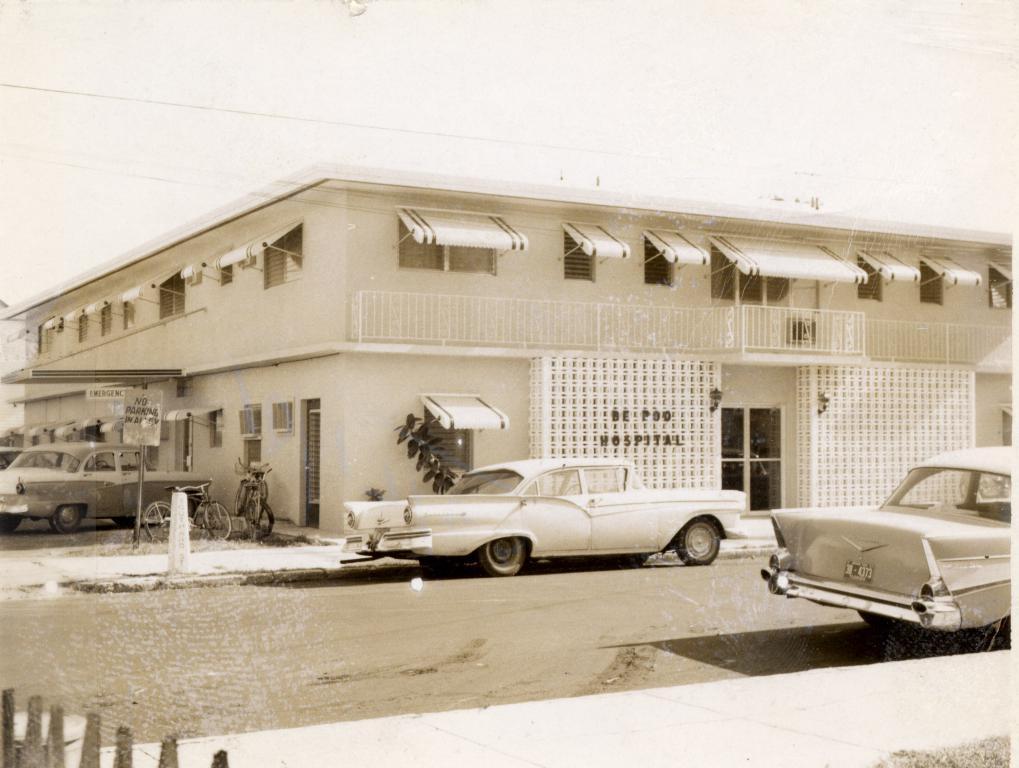Please provide a concise description of this image. It's a black and white image. In the middle a car is parked on the road and this is a house. 